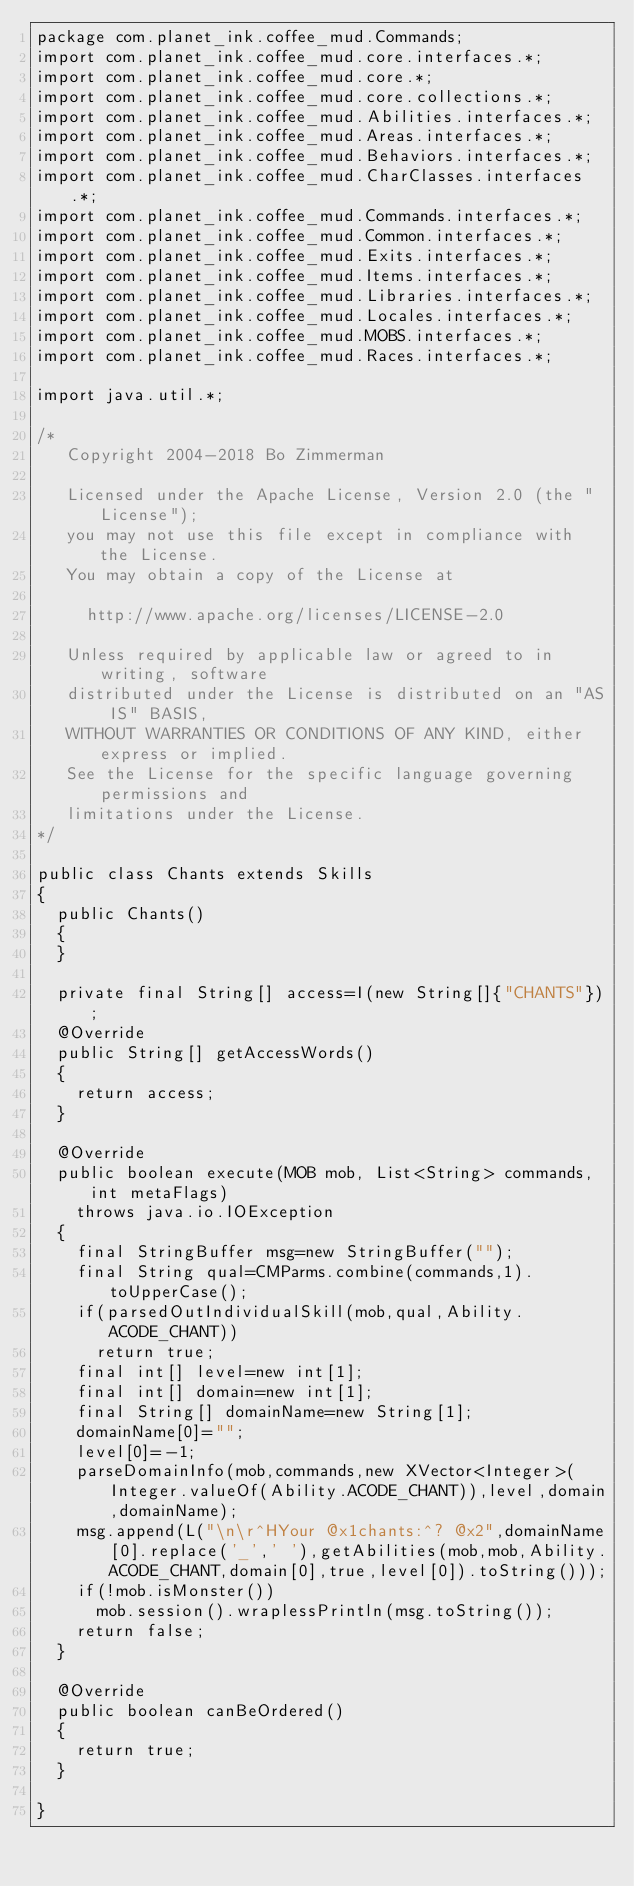Convert code to text. <code><loc_0><loc_0><loc_500><loc_500><_Java_>package com.planet_ink.coffee_mud.Commands;
import com.planet_ink.coffee_mud.core.interfaces.*;
import com.planet_ink.coffee_mud.core.*;
import com.planet_ink.coffee_mud.core.collections.*;
import com.planet_ink.coffee_mud.Abilities.interfaces.*;
import com.planet_ink.coffee_mud.Areas.interfaces.*;
import com.planet_ink.coffee_mud.Behaviors.interfaces.*;
import com.planet_ink.coffee_mud.CharClasses.interfaces.*;
import com.planet_ink.coffee_mud.Commands.interfaces.*;
import com.planet_ink.coffee_mud.Common.interfaces.*;
import com.planet_ink.coffee_mud.Exits.interfaces.*;
import com.planet_ink.coffee_mud.Items.interfaces.*;
import com.planet_ink.coffee_mud.Libraries.interfaces.*;
import com.planet_ink.coffee_mud.Locales.interfaces.*;
import com.planet_ink.coffee_mud.MOBS.interfaces.*;
import com.planet_ink.coffee_mud.Races.interfaces.*;

import java.util.*;

/*
   Copyright 2004-2018 Bo Zimmerman

   Licensed under the Apache License, Version 2.0 (the "License");
   you may not use this file except in compliance with the License.
   You may obtain a copy of the License at

	   http://www.apache.org/licenses/LICENSE-2.0

   Unless required by applicable law or agreed to in writing, software
   distributed under the License is distributed on an "AS IS" BASIS,
   WITHOUT WARRANTIES OR CONDITIONS OF ANY KIND, either express or implied.
   See the License for the specific language governing permissions and
   limitations under the License.
*/

public class Chants extends Skills
{
	public Chants()
	{
	}

	private final String[] access=I(new String[]{"CHANTS"});
	@Override
	public String[] getAccessWords()
	{
		return access;
	}

	@Override
	public boolean execute(MOB mob, List<String> commands, int metaFlags)
		throws java.io.IOException
	{
		final StringBuffer msg=new StringBuffer("");
		final String qual=CMParms.combine(commands,1).toUpperCase();
		if(parsedOutIndividualSkill(mob,qual,Ability.ACODE_CHANT))
			return true;
		final int[] level=new int[1];
		final int[] domain=new int[1];
		final String[] domainName=new String[1];
		domainName[0]="";
		level[0]=-1;
		parseDomainInfo(mob,commands,new XVector<Integer>(Integer.valueOf(Ability.ACODE_CHANT)),level,domain,domainName);
		msg.append(L("\n\r^HYour @x1chants:^? @x2",domainName[0].replace('_',' '),getAbilities(mob,mob,Ability.ACODE_CHANT,domain[0],true,level[0]).toString()));
		if(!mob.isMonster())
			mob.session().wraplessPrintln(msg.toString());
		return false;
	}

	@Override
	public boolean canBeOrdered()
	{
		return true;
	}

}
</code> 